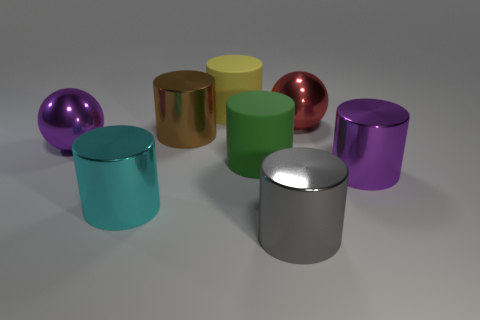Do the big metallic cylinder that is right of the gray cylinder and the metal ball left of the cyan metal thing have the same color?
Your answer should be very brief. Yes. There is a big sphere that is left of the gray metallic cylinder; what color is it?
Your response must be concise. Purple. The cylinder that is behind the big metallic cylinder that is behind the purple metal cylinder is made of what material?
Offer a terse response. Rubber. Are there any cyan metallic cylinders that have the same size as the yellow object?
Make the answer very short. Yes. How many objects are big rubber things in front of the big yellow rubber thing or big cylinders that are to the left of the yellow rubber cylinder?
Offer a very short reply. 3. There is a large metallic sphere on the right side of the big cyan cylinder; is there a large metal cylinder that is behind it?
Keep it short and to the point. No. There is a large purple cylinder; what number of large metallic balls are on the left side of it?
Keep it short and to the point. 2. Is the number of large cyan metallic cylinders to the right of the red metallic ball less than the number of large purple metal things behind the large green cylinder?
Give a very brief answer. Yes. What number of objects are either metal objects that are on the right side of the cyan cylinder or brown things?
Your answer should be very brief. 4. What is the size of the gray shiny thing that is the same shape as the big green matte object?
Ensure brevity in your answer.  Large. 